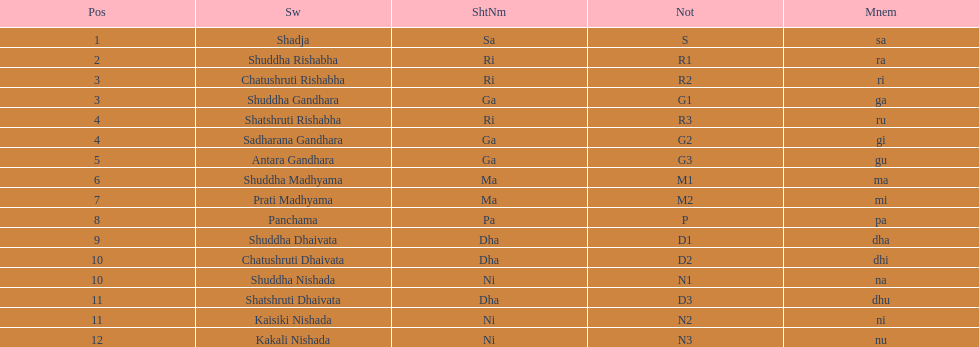Other than m1 how many notations have "1" in them? 4. 